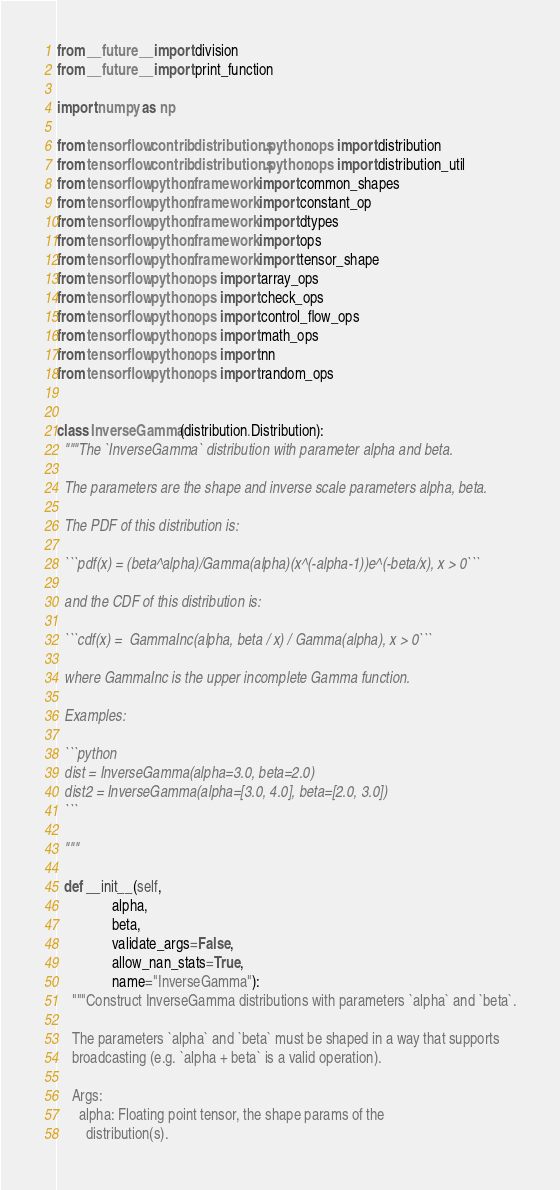<code> <loc_0><loc_0><loc_500><loc_500><_Python_>from __future__ import division
from __future__ import print_function

import numpy as np

from tensorflow.contrib.distributions.python.ops import distribution
from tensorflow.contrib.distributions.python.ops import distribution_util
from tensorflow.python.framework import common_shapes
from tensorflow.python.framework import constant_op
from tensorflow.python.framework import dtypes
from tensorflow.python.framework import ops
from tensorflow.python.framework import tensor_shape
from tensorflow.python.ops import array_ops
from tensorflow.python.ops import check_ops
from tensorflow.python.ops import control_flow_ops
from tensorflow.python.ops import math_ops
from tensorflow.python.ops import nn
from tensorflow.python.ops import random_ops


class InverseGamma(distribution.Distribution):
  """The `InverseGamma` distribution with parameter alpha and beta.

  The parameters are the shape and inverse scale parameters alpha, beta.

  The PDF of this distribution is:

  ```pdf(x) = (beta^alpha)/Gamma(alpha)(x^(-alpha-1))e^(-beta/x), x > 0```

  and the CDF of this distribution is:

  ```cdf(x) =  GammaInc(alpha, beta / x) / Gamma(alpha), x > 0```

  where GammaInc is the upper incomplete Gamma function.

  Examples:

  ```python
  dist = InverseGamma(alpha=3.0, beta=2.0)
  dist2 = InverseGamma(alpha=[3.0, 4.0], beta=[2.0, 3.0])
  ```

  """

  def __init__(self,
               alpha,
               beta,
               validate_args=False,
               allow_nan_stats=True,
               name="InverseGamma"):
    """Construct InverseGamma distributions with parameters `alpha` and `beta`.

    The parameters `alpha` and `beta` must be shaped in a way that supports
    broadcasting (e.g. `alpha + beta` is a valid operation).

    Args:
      alpha: Floating point tensor, the shape params of the
        distribution(s).</code> 